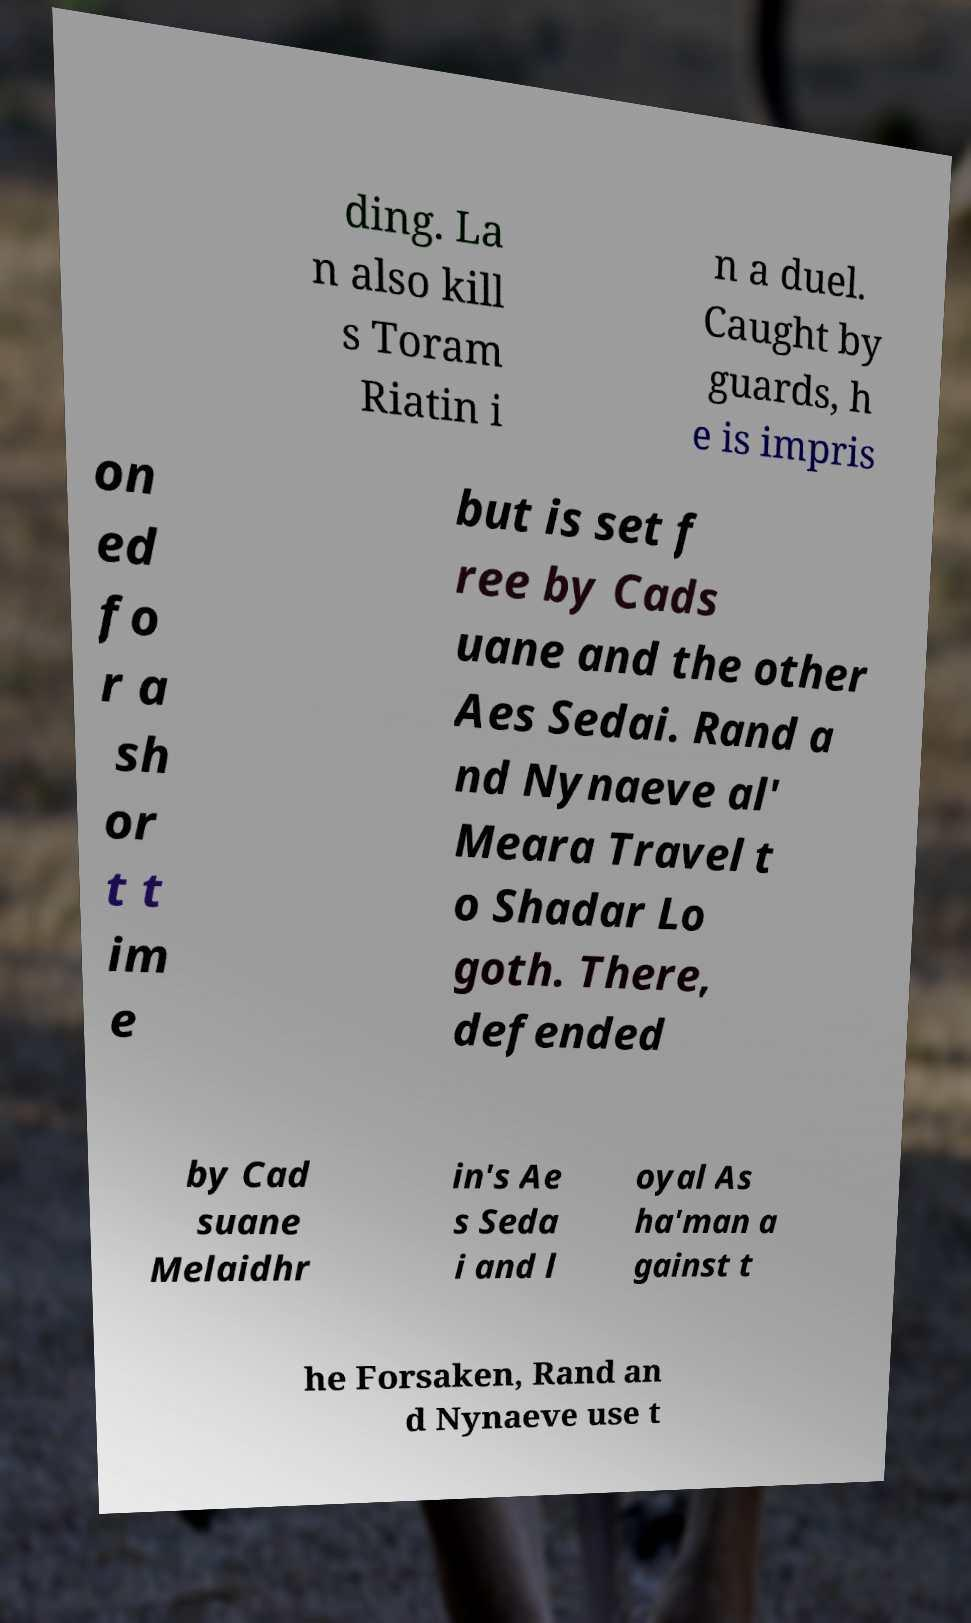Could you assist in decoding the text presented in this image and type it out clearly? ding. La n also kill s Toram Riatin i n a duel. Caught by guards, h e is impris on ed fo r a sh or t t im e but is set f ree by Cads uane and the other Aes Sedai. Rand a nd Nynaeve al' Meara Travel t o Shadar Lo goth. There, defended by Cad suane Melaidhr in's Ae s Seda i and l oyal As ha'man a gainst t he Forsaken, Rand an d Nynaeve use t 